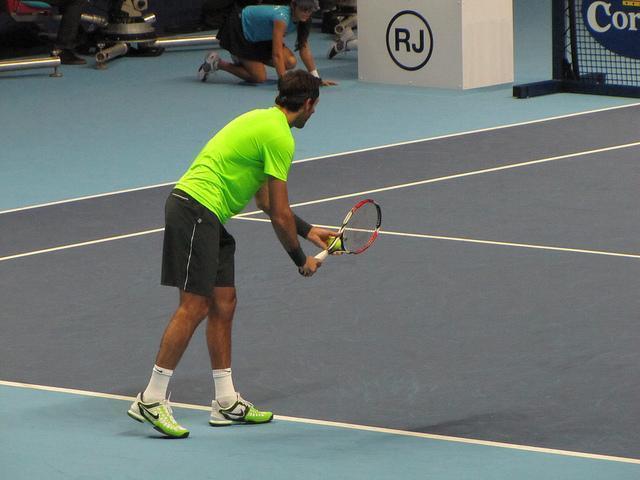How many people are there?
Give a very brief answer. 3. How many people are holding book in their hand ?
Give a very brief answer. 0. 